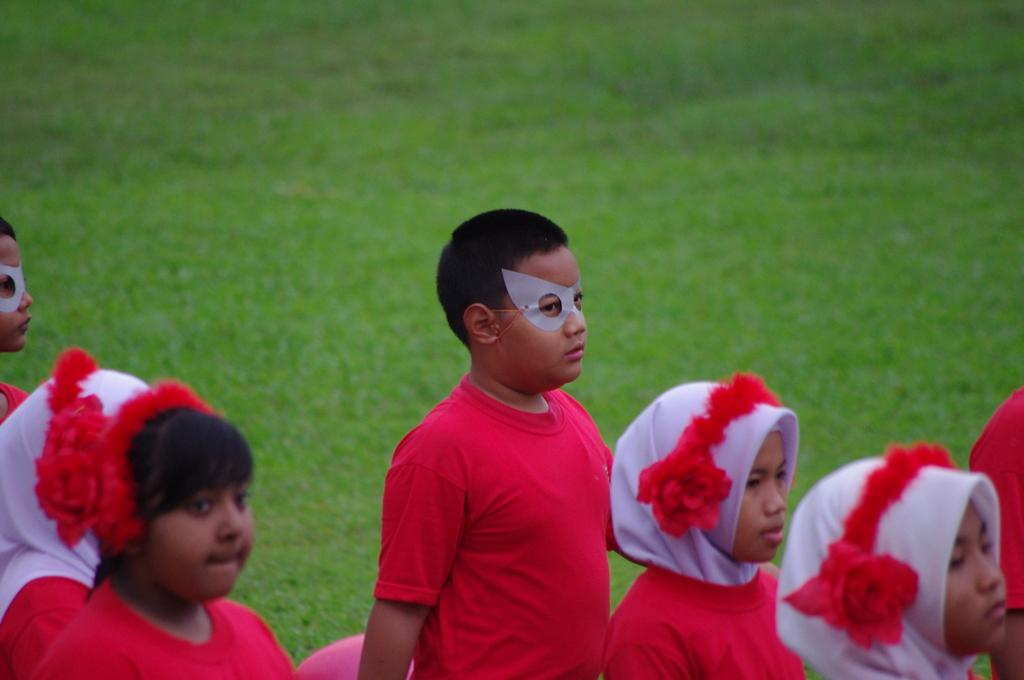Who is present in the image? There are little kids in the image. What is the surface that the kids are on? The kids are on the surface of the grass. What type of button can be seen on the cent in the image? There is no button or cent present in the image; it features little kids on the grass. Where is the zoo located in the image? There is no zoo present in the image; it features little kids on the grass. 